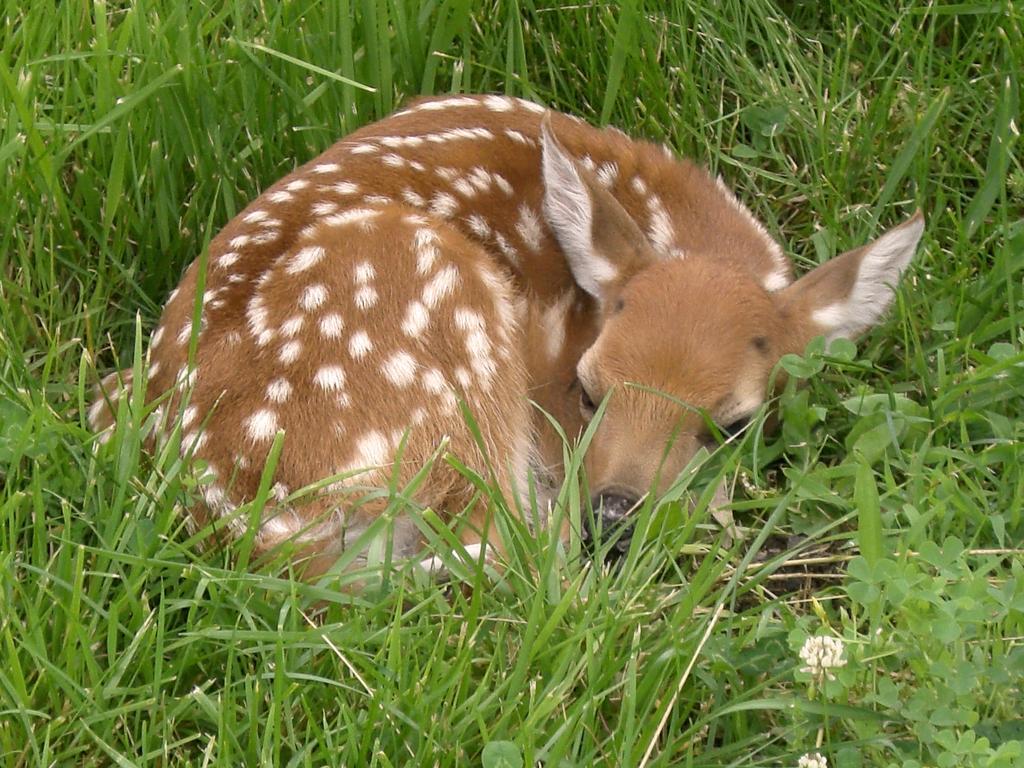Describe this image in one or two sentences. In this picture there is a deer in the center of the image, on the grassland and there is grass around the area of the image. 